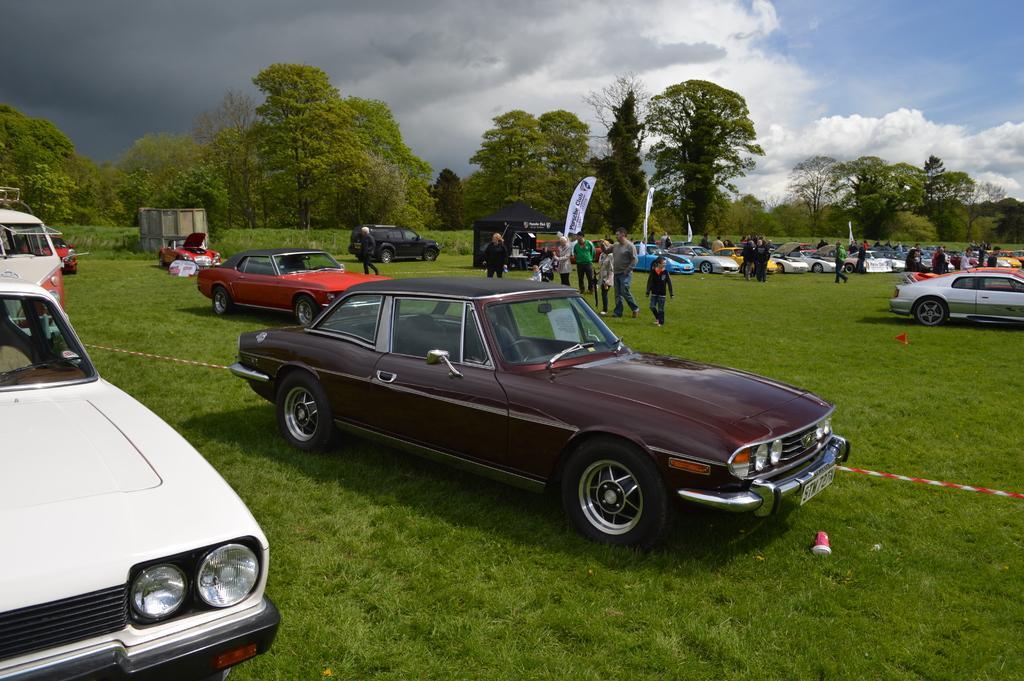In one or two sentences, can you explain what this image depicts? In this image we can see some people, cars parked aside, flag, a tent on the grass. On the backside we can see some trees, plants and the sky which looks cloudy. 